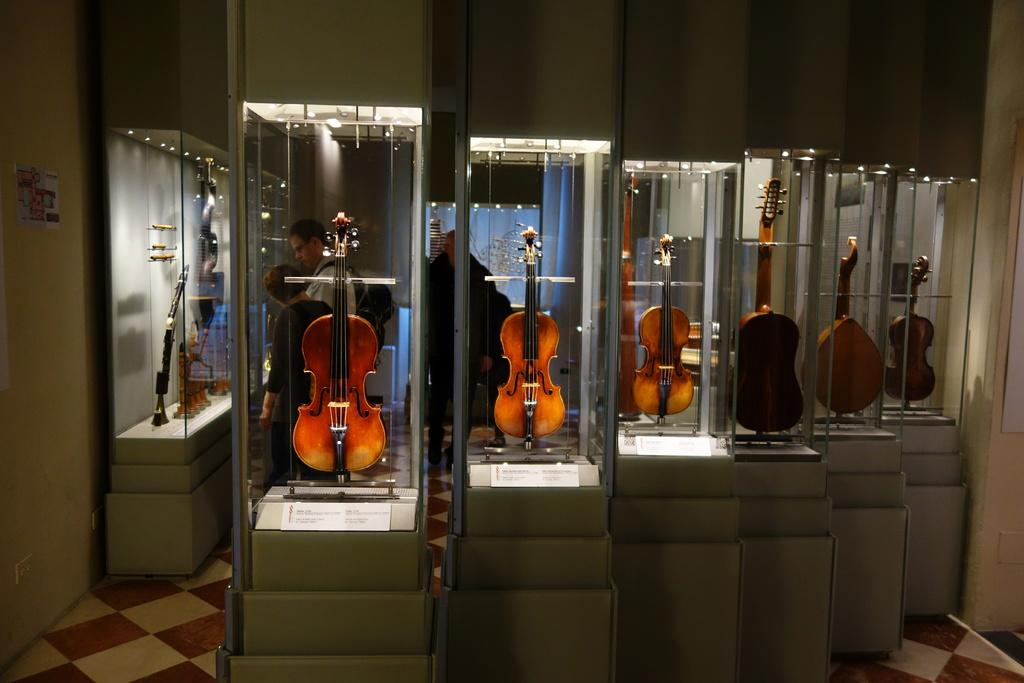What types of musical instruments can be seen in the image? There are a violin, piano, trumpet, and guitar in the image. How are the musical instruments displayed in the image? The musical instruments are kept in a showcase. What is the floor made of in the image? The floor is made of tiles. What type of paste is being used to play the trumpet in the image? There is no paste being used to play the trumpet in the image; it is played by blowing air through it. 